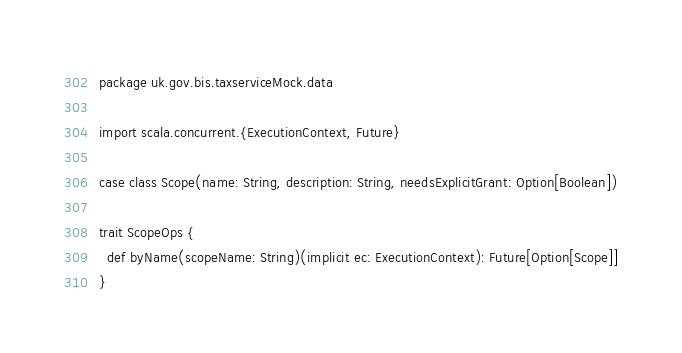<code> <loc_0><loc_0><loc_500><loc_500><_Scala_>package uk.gov.bis.taxserviceMock.data

import scala.concurrent.{ExecutionContext, Future}

case class Scope(name: String, description: String, needsExplicitGrant: Option[Boolean])

trait ScopeOps {
  def byName(scopeName: String)(implicit ec: ExecutionContext): Future[Option[Scope]]
}
</code> 